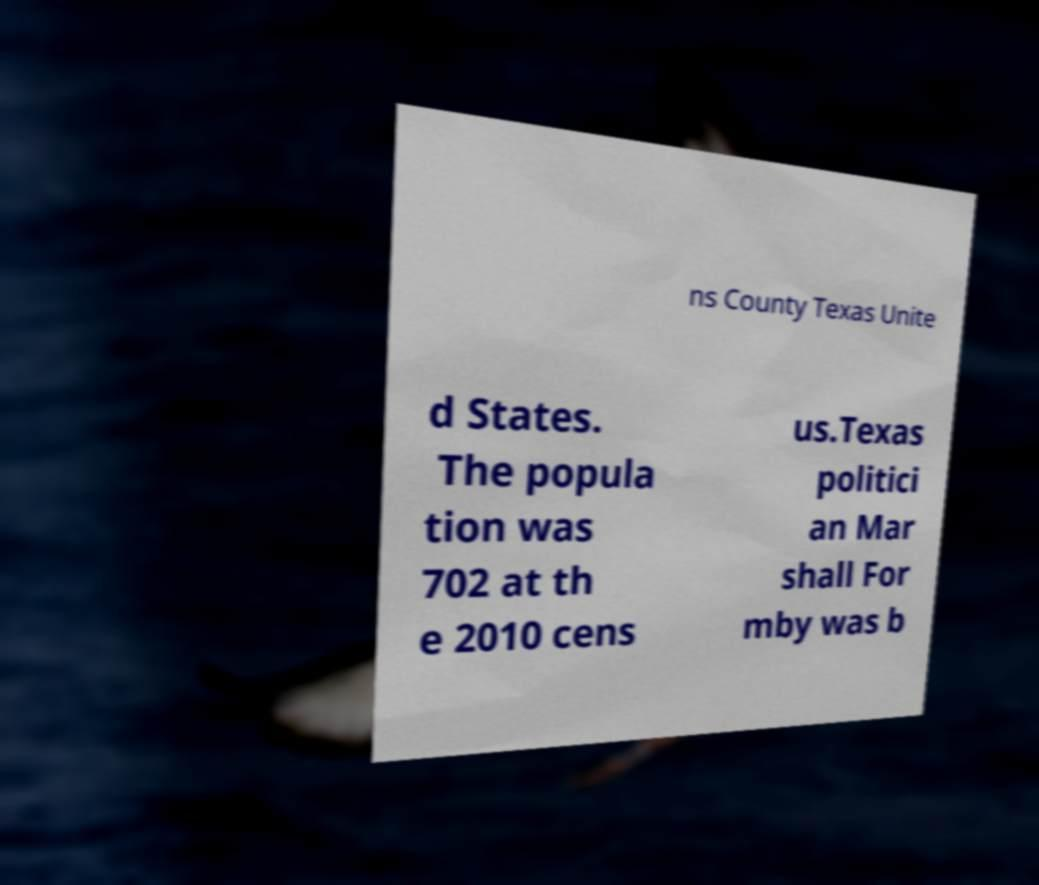Can you accurately transcribe the text from the provided image for me? ns County Texas Unite d States. The popula tion was 702 at th e 2010 cens us.Texas politici an Mar shall For mby was b 